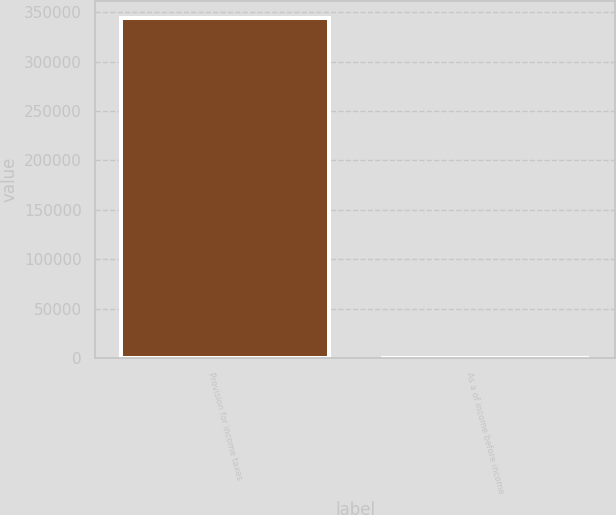Convert chart to OTSL. <chart><loc_0><loc_0><loc_500><loc_500><bar_chart><fcel>Provision for income taxes<fcel>As a of income before income<nl><fcel>343885<fcel>30<nl></chart> 